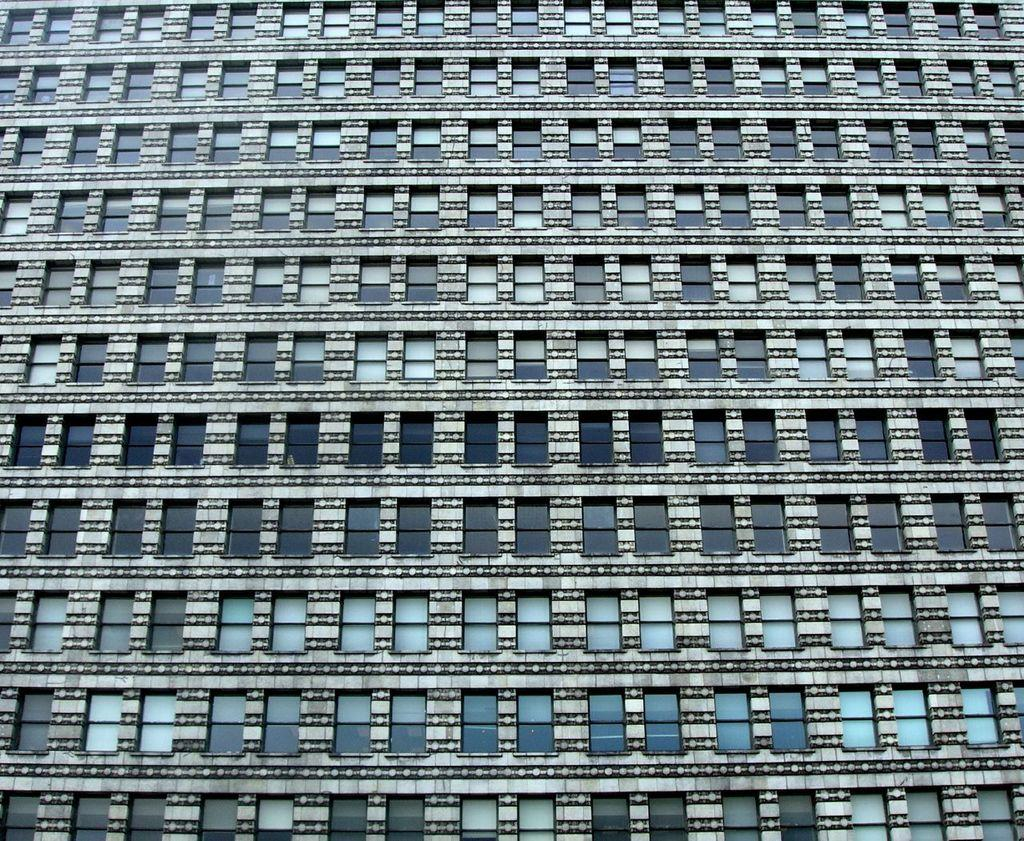What is the main subject in the image? There is a structure in the image that resembles a building. Can you describe any specific features of the building? The building has windows. What type of crayon can be seen in the image? There is no crayon present in the image. How many clocks are hanging on the walls of the building in the image? There is no information about clocks or their presence in the image. 